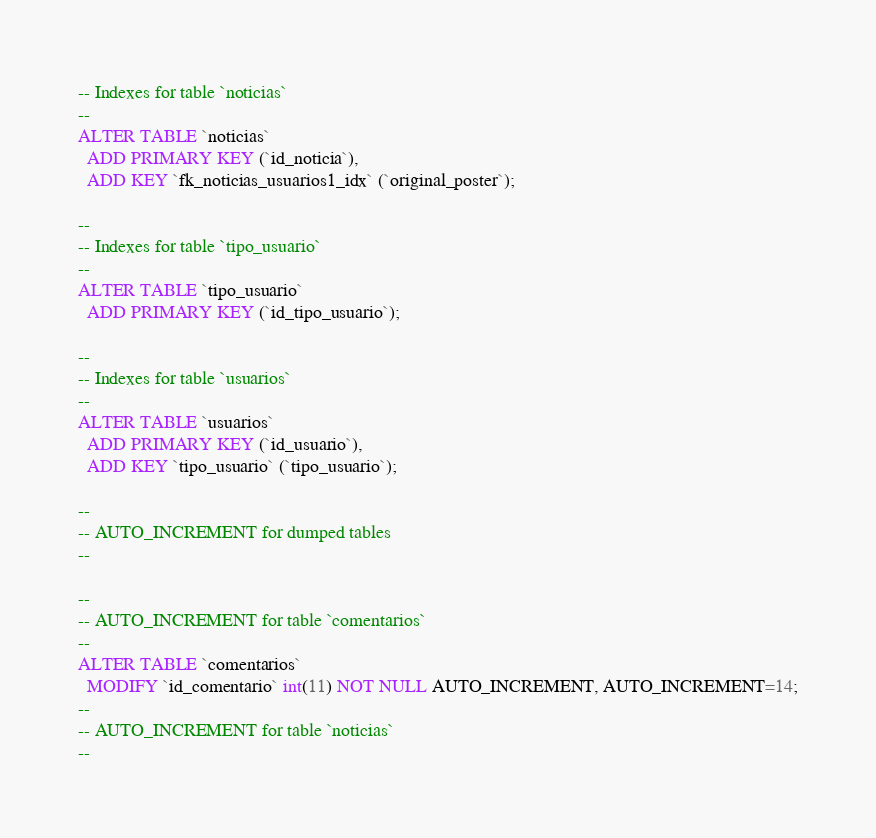Convert code to text. <code><loc_0><loc_0><loc_500><loc_500><_SQL_>-- Indexes for table `noticias`
--
ALTER TABLE `noticias`
  ADD PRIMARY KEY (`id_noticia`),
  ADD KEY `fk_noticias_usuarios1_idx` (`original_poster`);

--
-- Indexes for table `tipo_usuario`
--
ALTER TABLE `tipo_usuario`
  ADD PRIMARY KEY (`id_tipo_usuario`);

--
-- Indexes for table `usuarios`
--
ALTER TABLE `usuarios`
  ADD PRIMARY KEY (`id_usuario`),
  ADD KEY `tipo_usuario` (`tipo_usuario`);

--
-- AUTO_INCREMENT for dumped tables
--

--
-- AUTO_INCREMENT for table `comentarios`
--
ALTER TABLE `comentarios`
  MODIFY `id_comentario` int(11) NOT NULL AUTO_INCREMENT, AUTO_INCREMENT=14;
--
-- AUTO_INCREMENT for table `noticias`
--</code> 